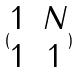<formula> <loc_0><loc_0><loc_500><loc_500>( \begin{matrix} 1 & N \\ 1 & 1 \end{matrix} )</formula> 